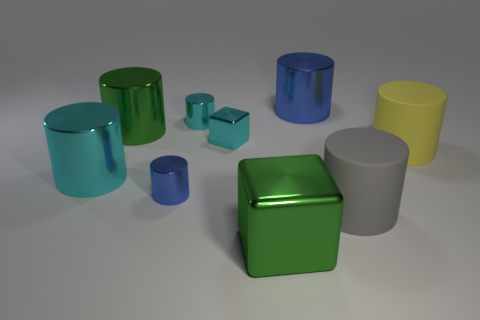Is the number of big gray matte cylinders less than the number of tiny red shiny blocks?
Ensure brevity in your answer.  No. There is a green thing that is in front of the large green thing to the left of the tiny shiny cube; what is it made of?
Your response must be concise. Metal. Do the yellow cylinder and the cyan block have the same size?
Ensure brevity in your answer.  No. How many things are either large green metallic things or large metal cylinders?
Ensure brevity in your answer.  4. What size is the object that is both in front of the tiny blue cylinder and left of the large blue cylinder?
Ensure brevity in your answer.  Large. Is the number of gray cylinders in front of the gray rubber cylinder less than the number of brown shiny balls?
Provide a short and direct response. No. What is the shape of the big green object that is made of the same material as the big green cylinder?
Your response must be concise. Cube. There is a large green thing that is in front of the cyan metal block; is it the same shape as the blue object that is behind the small blue metal thing?
Keep it short and to the point. No. Are there fewer small metal cylinders that are behind the large blue shiny cylinder than tiny cylinders in front of the large cube?
Offer a very short reply. No. What is the shape of the thing that is the same color as the large cube?
Make the answer very short. Cylinder. 